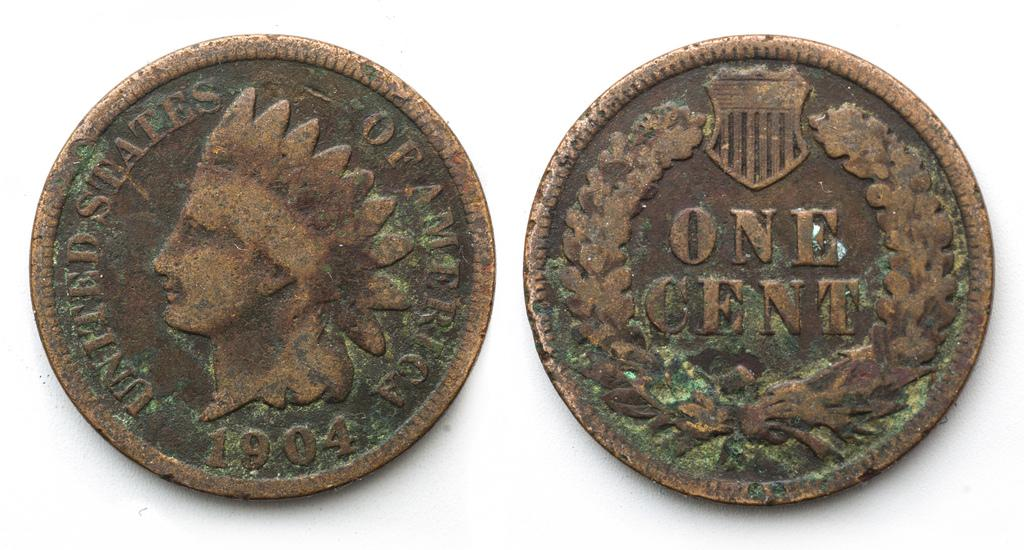<image>
Offer a succinct explanation of the picture presented. Two old coins with one side reading United STates of America and the other One Cent 